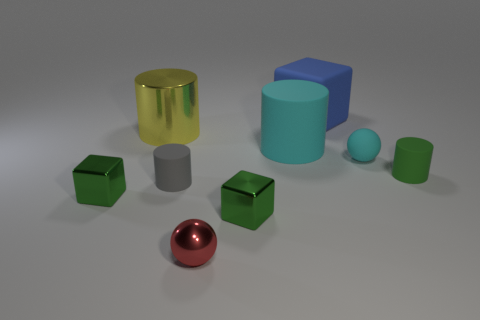Are there any other things of the same color as the large rubber cylinder?
Your response must be concise. Yes. Does the tiny rubber sphere have the same color as the big cylinder in front of the big yellow thing?
Provide a succinct answer. Yes. There is a sphere that is right of the blue matte thing; is its color the same as the large matte cylinder?
Ensure brevity in your answer.  Yes. Is there a rubber object that has the same color as the small rubber ball?
Provide a succinct answer. Yes. Do the rubber ball and the big matte cylinder have the same color?
Your answer should be very brief. Yes. There is a big rubber thing that is the same color as the tiny rubber sphere; what is its shape?
Provide a short and direct response. Cylinder. The other rubber cylinder that is the same size as the yellow cylinder is what color?
Your answer should be very brief. Cyan. What number of things are big rubber things that are right of the large cyan rubber object or cyan metal blocks?
Your answer should be very brief. 1. What is the size of the cylinder that is behind the small gray cylinder and left of the small red thing?
Your answer should be compact. Large. There is a rubber object that is the same color as the large matte cylinder; what size is it?
Make the answer very short. Small. 